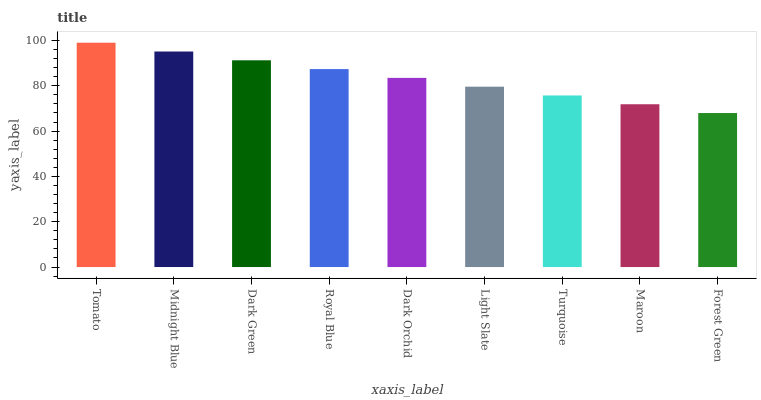Is Forest Green the minimum?
Answer yes or no. Yes. Is Tomato the maximum?
Answer yes or no. Yes. Is Midnight Blue the minimum?
Answer yes or no. No. Is Midnight Blue the maximum?
Answer yes or no. No. Is Tomato greater than Midnight Blue?
Answer yes or no. Yes. Is Midnight Blue less than Tomato?
Answer yes or no. Yes. Is Midnight Blue greater than Tomato?
Answer yes or no. No. Is Tomato less than Midnight Blue?
Answer yes or no. No. Is Dark Orchid the high median?
Answer yes or no. Yes. Is Dark Orchid the low median?
Answer yes or no. Yes. Is Maroon the high median?
Answer yes or no. No. Is Turquoise the low median?
Answer yes or no. No. 